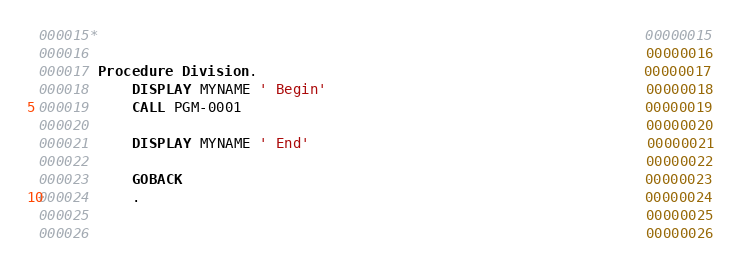Convert code to text. <code><loc_0><loc_0><loc_500><loc_500><_COBOL_>000015*                                                                 00000015
000016                                                                  00000016
000017 Procedure Division.                                              00000017
000018     DISPLAY MYNAME ' Begin'                                      00000018
000019     CALL PGM-0001                                                00000019
000020                                                                  00000020
000021     DISPLAY MYNAME ' End'                                        00000021
000022                                                                  00000022
000023     GOBACK                                                       00000023
000024     .                                                            00000024
000025                                                                  00000025
000026                                                                  00000026
</code> 